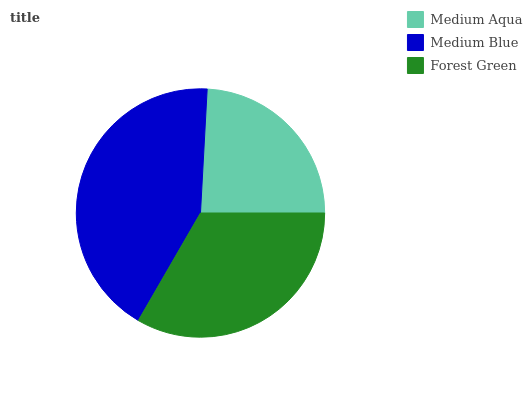Is Medium Aqua the minimum?
Answer yes or no. Yes. Is Medium Blue the maximum?
Answer yes or no. Yes. Is Forest Green the minimum?
Answer yes or no. No. Is Forest Green the maximum?
Answer yes or no. No. Is Medium Blue greater than Forest Green?
Answer yes or no. Yes. Is Forest Green less than Medium Blue?
Answer yes or no. Yes. Is Forest Green greater than Medium Blue?
Answer yes or no. No. Is Medium Blue less than Forest Green?
Answer yes or no. No. Is Forest Green the high median?
Answer yes or no. Yes. Is Forest Green the low median?
Answer yes or no. Yes. Is Medium Aqua the high median?
Answer yes or no. No. Is Medium Blue the low median?
Answer yes or no. No. 